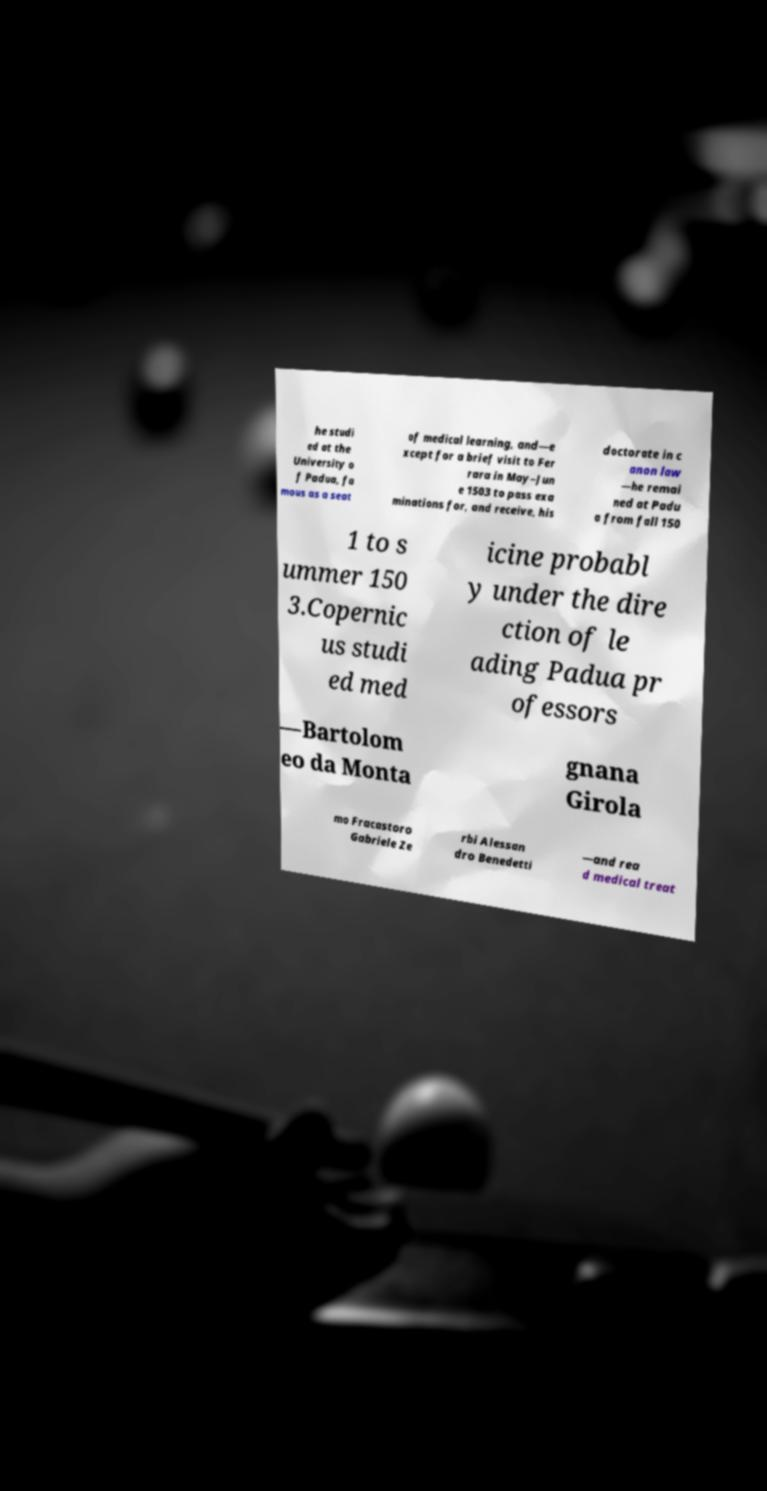What messages or text are displayed in this image? I need them in a readable, typed format. he studi ed at the University o f Padua, fa mous as a seat of medical learning, and—e xcept for a brief visit to Fer rara in May–Jun e 1503 to pass exa minations for, and receive, his doctorate in c anon law —he remai ned at Padu a from fall 150 1 to s ummer 150 3.Copernic us studi ed med icine probabl y under the dire ction of le ading Padua pr ofessors —Bartolom eo da Monta gnana Girola mo Fracastoro Gabriele Ze rbi Alessan dro Benedetti —and rea d medical treat 